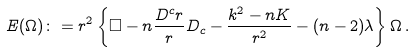<formula> <loc_0><loc_0><loc_500><loc_500>E ( \Omega ) \colon = r ^ { 2 } \left \{ \square - n \frac { D ^ { c } r } { r } D _ { c } - \frac { k ^ { 2 } - n K } { r ^ { 2 } } - ( n - 2 ) \lambda \right \} \Omega \, .</formula> 